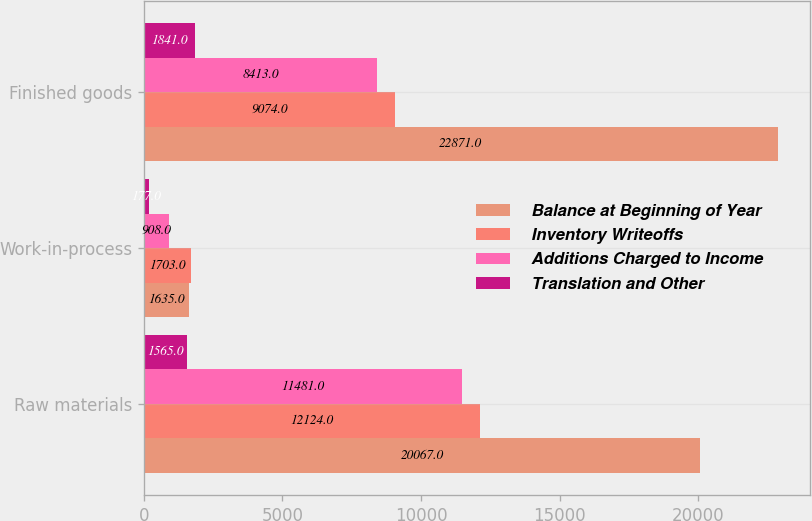<chart> <loc_0><loc_0><loc_500><loc_500><stacked_bar_chart><ecel><fcel>Raw materials<fcel>Work-in-process<fcel>Finished goods<nl><fcel>Balance at Beginning of Year<fcel>20067<fcel>1635<fcel>22871<nl><fcel>Inventory Writeoffs<fcel>12124<fcel>1703<fcel>9074<nl><fcel>Additions Charged to Income<fcel>11481<fcel>908<fcel>8413<nl><fcel>Translation and Other<fcel>1565<fcel>177<fcel>1841<nl></chart> 